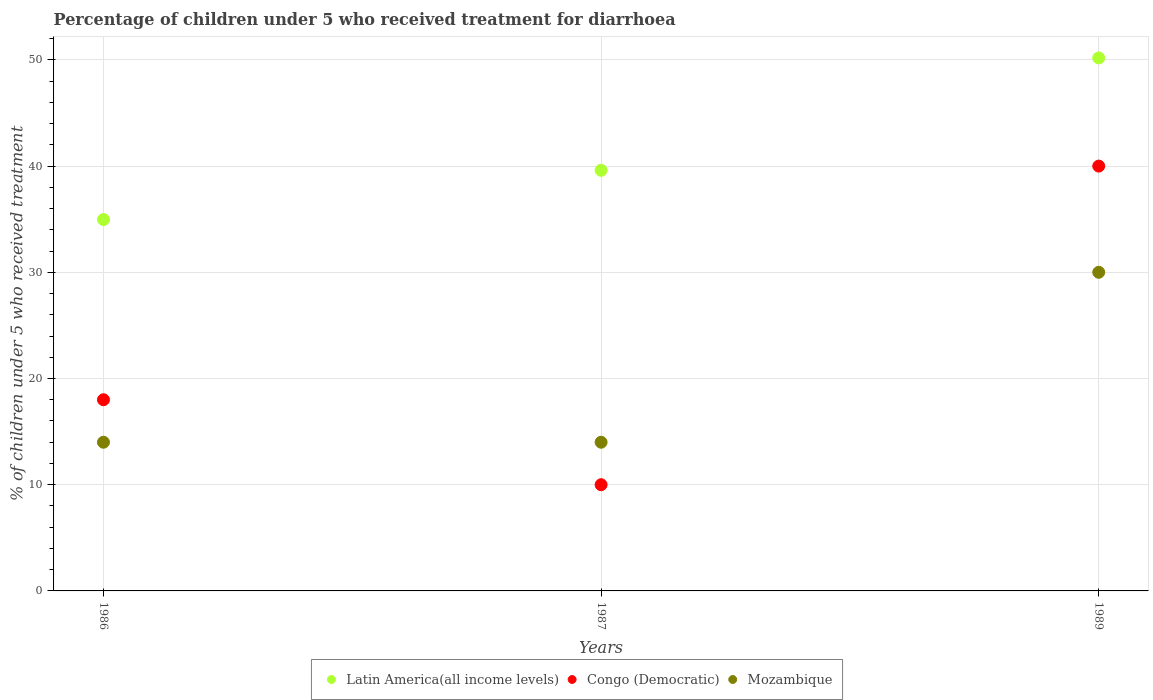How many different coloured dotlines are there?
Keep it short and to the point. 3. Is the number of dotlines equal to the number of legend labels?
Provide a succinct answer. Yes. Across all years, what is the maximum percentage of children who received treatment for diarrhoea  in Latin America(all income levels)?
Provide a succinct answer. 50.19. Across all years, what is the minimum percentage of children who received treatment for diarrhoea  in Latin America(all income levels)?
Your response must be concise. 34.97. What is the difference between the percentage of children who received treatment for diarrhoea  in Latin America(all income levels) in 1986 and the percentage of children who received treatment for diarrhoea  in Mozambique in 1987?
Your response must be concise. 20.97. What is the average percentage of children who received treatment for diarrhoea  in Latin America(all income levels) per year?
Your answer should be compact. 41.59. In the year 1987, what is the difference between the percentage of children who received treatment for diarrhoea  in Latin America(all income levels) and percentage of children who received treatment for diarrhoea  in Mozambique?
Your response must be concise. 25.6. In how many years, is the percentage of children who received treatment for diarrhoea  in Congo (Democratic) greater than 24 %?
Keep it short and to the point. 1. What is the ratio of the percentage of children who received treatment for diarrhoea  in Mozambique in 1986 to that in 1989?
Provide a short and direct response. 0.47. What is the difference between the highest and the second highest percentage of children who received treatment for diarrhoea  in Congo (Democratic)?
Offer a terse response. 22. Is the sum of the percentage of children who received treatment for diarrhoea  in Latin America(all income levels) in 1987 and 1989 greater than the maximum percentage of children who received treatment for diarrhoea  in Congo (Democratic) across all years?
Keep it short and to the point. Yes. Does the percentage of children who received treatment for diarrhoea  in Latin America(all income levels) monotonically increase over the years?
Provide a succinct answer. Yes. Is the percentage of children who received treatment for diarrhoea  in Latin America(all income levels) strictly less than the percentage of children who received treatment for diarrhoea  in Congo (Democratic) over the years?
Make the answer very short. No. Does the graph contain grids?
Ensure brevity in your answer.  Yes. What is the title of the graph?
Give a very brief answer. Percentage of children under 5 who received treatment for diarrhoea. What is the label or title of the X-axis?
Your response must be concise. Years. What is the label or title of the Y-axis?
Your answer should be very brief. % of children under 5 who received treatment. What is the % of children under 5 who received treatment in Latin America(all income levels) in 1986?
Keep it short and to the point. 34.97. What is the % of children under 5 who received treatment of Congo (Democratic) in 1986?
Give a very brief answer. 18. What is the % of children under 5 who received treatment in Mozambique in 1986?
Offer a very short reply. 14. What is the % of children under 5 who received treatment in Latin America(all income levels) in 1987?
Ensure brevity in your answer.  39.6. What is the % of children under 5 who received treatment in Congo (Democratic) in 1987?
Your answer should be very brief. 10. What is the % of children under 5 who received treatment in Latin America(all income levels) in 1989?
Make the answer very short. 50.19. What is the % of children under 5 who received treatment of Congo (Democratic) in 1989?
Give a very brief answer. 40. Across all years, what is the maximum % of children under 5 who received treatment in Latin America(all income levels)?
Your answer should be very brief. 50.19. Across all years, what is the maximum % of children under 5 who received treatment of Mozambique?
Provide a succinct answer. 30. Across all years, what is the minimum % of children under 5 who received treatment in Latin America(all income levels)?
Your answer should be very brief. 34.97. Across all years, what is the minimum % of children under 5 who received treatment of Mozambique?
Provide a short and direct response. 14. What is the total % of children under 5 who received treatment in Latin America(all income levels) in the graph?
Make the answer very short. 124.76. What is the total % of children under 5 who received treatment in Congo (Democratic) in the graph?
Give a very brief answer. 68. What is the difference between the % of children under 5 who received treatment in Latin America(all income levels) in 1986 and that in 1987?
Offer a terse response. -4.64. What is the difference between the % of children under 5 who received treatment in Congo (Democratic) in 1986 and that in 1987?
Your answer should be compact. 8. What is the difference between the % of children under 5 who received treatment in Latin America(all income levels) in 1986 and that in 1989?
Offer a terse response. -15.22. What is the difference between the % of children under 5 who received treatment of Mozambique in 1986 and that in 1989?
Your response must be concise. -16. What is the difference between the % of children under 5 who received treatment in Latin America(all income levels) in 1987 and that in 1989?
Provide a short and direct response. -10.58. What is the difference between the % of children under 5 who received treatment of Congo (Democratic) in 1987 and that in 1989?
Keep it short and to the point. -30. What is the difference between the % of children under 5 who received treatment of Mozambique in 1987 and that in 1989?
Offer a terse response. -16. What is the difference between the % of children under 5 who received treatment in Latin America(all income levels) in 1986 and the % of children under 5 who received treatment in Congo (Democratic) in 1987?
Ensure brevity in your answer.  24.97. What is the difference between the % of children under 5 who received treatment of Latin America(all income levels) in 1986 and the % of children under 5 who received treatment of Mozambique in 1987?
Keep it short and to the point. 20.97. What is the difference between the % of children under 5 who received treatment of Congo (Democratic) in 1986 and the % of children under 5 who received treatment of Mozambique in 1987?
Offer a terse response. 4. What is the difference between the % of children under 5 who received treatment of Latin America(all income levels) in 1986 and the % of children under 5 who received treatment of Congo (Democratic) in 1989?
Your response must be concise. -5.03. What is the difference between the % of children under 5 who received treatment of Latin America(all income levels) in 1986 and the % of children under 5 who received treatment of Mozambique in 1989?
Give a very brief answer. 4.97. What is the difference between the % of children under 5 who received treatment of Latin America(all income levels) in 1987 and the % of children under 5 who received treatment of Congo (Democratic) in 1989?
Keep it short and to the point. -0.4. What is the difference between the % of children under 5 who received treatment of Latin America(all income levels) in 1987 and the % of children under 5 who received treatment of Mozambique in 1989?
Your answer should be compact. 9.6. What is the average % of children under 5 who received treatment in Latin America(all income levels) per year?
Provide a succinct answer. 41.59. What is the average % of children under 5 who received treatment in Congo (Democratic) per year?
Ensure brevity in your answer.  22.67. What is the average % of children under 5 who received treatment in Mozambique per year?
Keep it short and to the point. 19.33. In the year 1986, what is the difference between the % of children under 5 who received treatment of Latin America(all income levels) and % of children under 5 who received treatment of Congo (Democratic)?
Offer a terse response. 16.97. In the year 1986, what is the difference between the % of children under 5 who received treatment in Latin America(all income levels) and % of children under 5 who received treatment in Mozambique?
Ensure brevity in your answer.  20.97. In the year 1987, what is the difference between the % of children under 5 who received treatment in Latin America(all income levels) and % of children under 5 who received treatment in Congo (Democratic)?
Give a very brief answer. 29.6. In the year 1987, what is the difference between the % of children under 5 who received treatment in Latin America(all income levels) and % of children under 5 who received treatment in Mozambique?
Offer a very short reply. 25.6. In the year 1987, what is the difference between the % of children under 5 who received treatment of Congo (Democratic) and % of children under 5 who received treatment of Mozambique?
Offer a very short reply. -4. In the year 1989, what is the difference between the % of children under 5 who received treatment of Latin America(all income levels) and % of children under 5 who received treatment of Congo (Democratic)?
Give a very brief answer. 10.19. In the year 1989, what is the difference between the % of children under 5 who received treatment of Latin America(all income levels) and % of children under 5 who received treatment of Mozambique?
Give a very brief answer. 20.19. In the year 1989, what is the difference between the % of children under 5 who received treatment in Congo (Democratic) and % of children under 5 who received treatment in Mozambique?
Your answer should be compact. 10. What is the ratio of the % of children under 5 who received treatment in Latin America(all income levels) in 1986 to that in 1987?
Offer a terse response. 0.88. What is the ratio of the % of children under 5 who received treatment in Latin America(all income levels) in 1986 to that in 1989?
Keep it short and to the point. 0.7. What is the ratio of the % of children under 5 who received treatment of Congo (Democratic) in 1986 to that in 1989?
Offer a terse response. 0.45. What is the ratio of the % of children under 5 who received treatment in Mozambique in 1986 to that in 1989?
Provide a short and direct response. 0.47. What is the ratio of the % of children under 5 who received treatment of Latin America(all income levels) in 1987 to that in 1989?
Your answer should be compact. 0.79. What is the ratio of the % of children under 5 who received treatment of Mozambique in 1987 to that in 1989?
Offer a very short reply. 0.47. What is the difference between the highest and the second highest % of children under 5 who received treatment in Latin America(all income levels)?
Offer a very short reply. 10.58. What is the difference between the highest and the second highest % of children under 5 who received treatment of Mozambique?
Give a very brief answer. 16. What is the difference between the highest and the lowest % of children under 5 who received treatment of Latin America(all income levels)?
Your response must be concise. 15.22. What is the difference between the highest and the lowest % of children under 5 who received treatment of Mozambique?
Your answer should be compact. 16. 